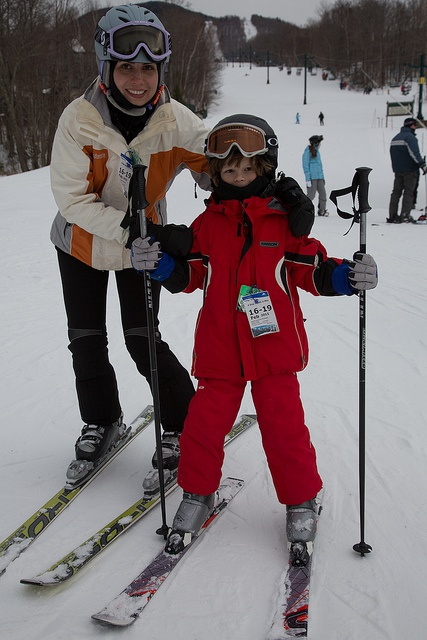Describe the objects in this image and their specific colors. I can see people in black, maroon, and gray tones, people in black, darkgray, gray, and maroon tones, skis in black, darkgray, gray, and olive tones, skis in black, darkgray, and gray tones, and people in black, gray, and darkgray tones in this image. 